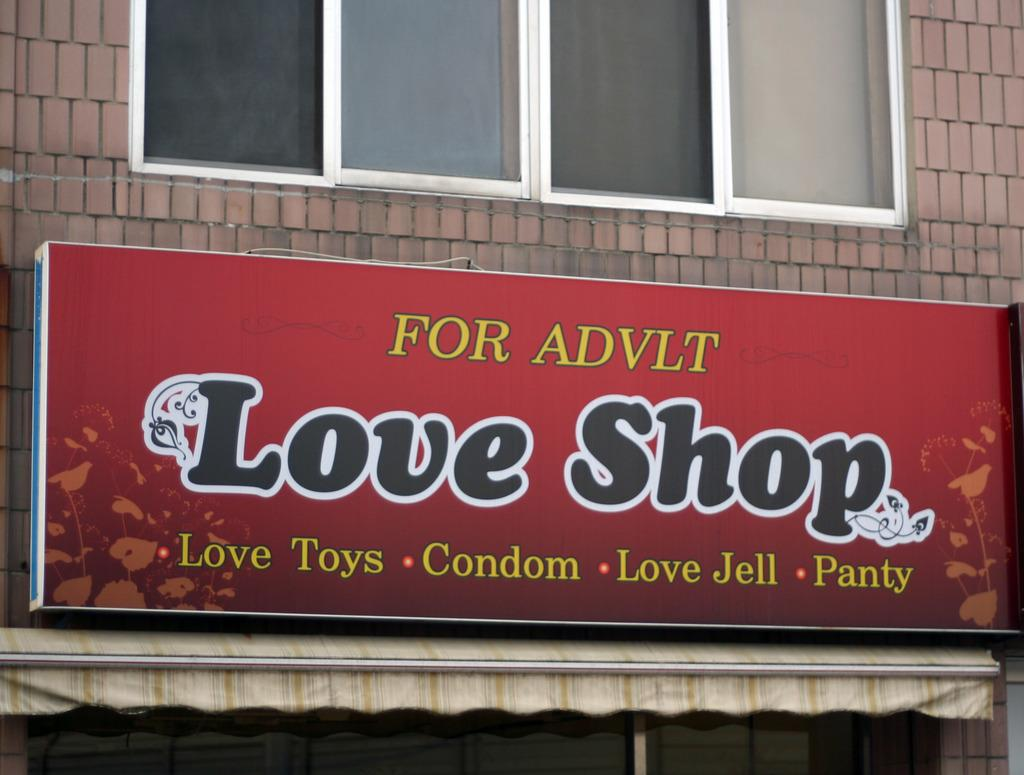Where was the image taken? The image is taken outdoors. What can be seen in the background of the image? There is a building in the image. Can you describe the building in the image? The building has a wall and windows. What is in the middle of the image? There is a board with text in the middle of the image. What type of camp can be seen in the image? There is no camp present in the image; it features a building with a wall and windows, as well as a board with text. Can you describe the nerves of the person in the image? There is no person present in the image, so it is not possible to describe their nerves. 